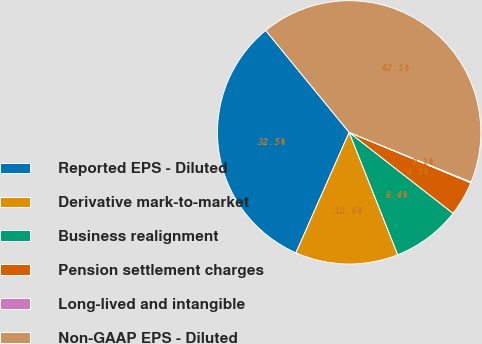Convert chart to OTSL. <chart><loc_0><loc_0><loc_500><loc_500><pie_chart><fcel>Reported EPS - Diluted<fcel>Derivative mark-to-market<fcel>Business realignment<fcel>Pension settlement charges<fcel>Long-lived and intangible<fcel>Non-GAAP EPS - Diluted<nl><fcel>32.46%<fcel>12.63%<fcel>8.45%<fcel>4.28%<fcel>0.1%<fcel>42.08%<nl></chart> 